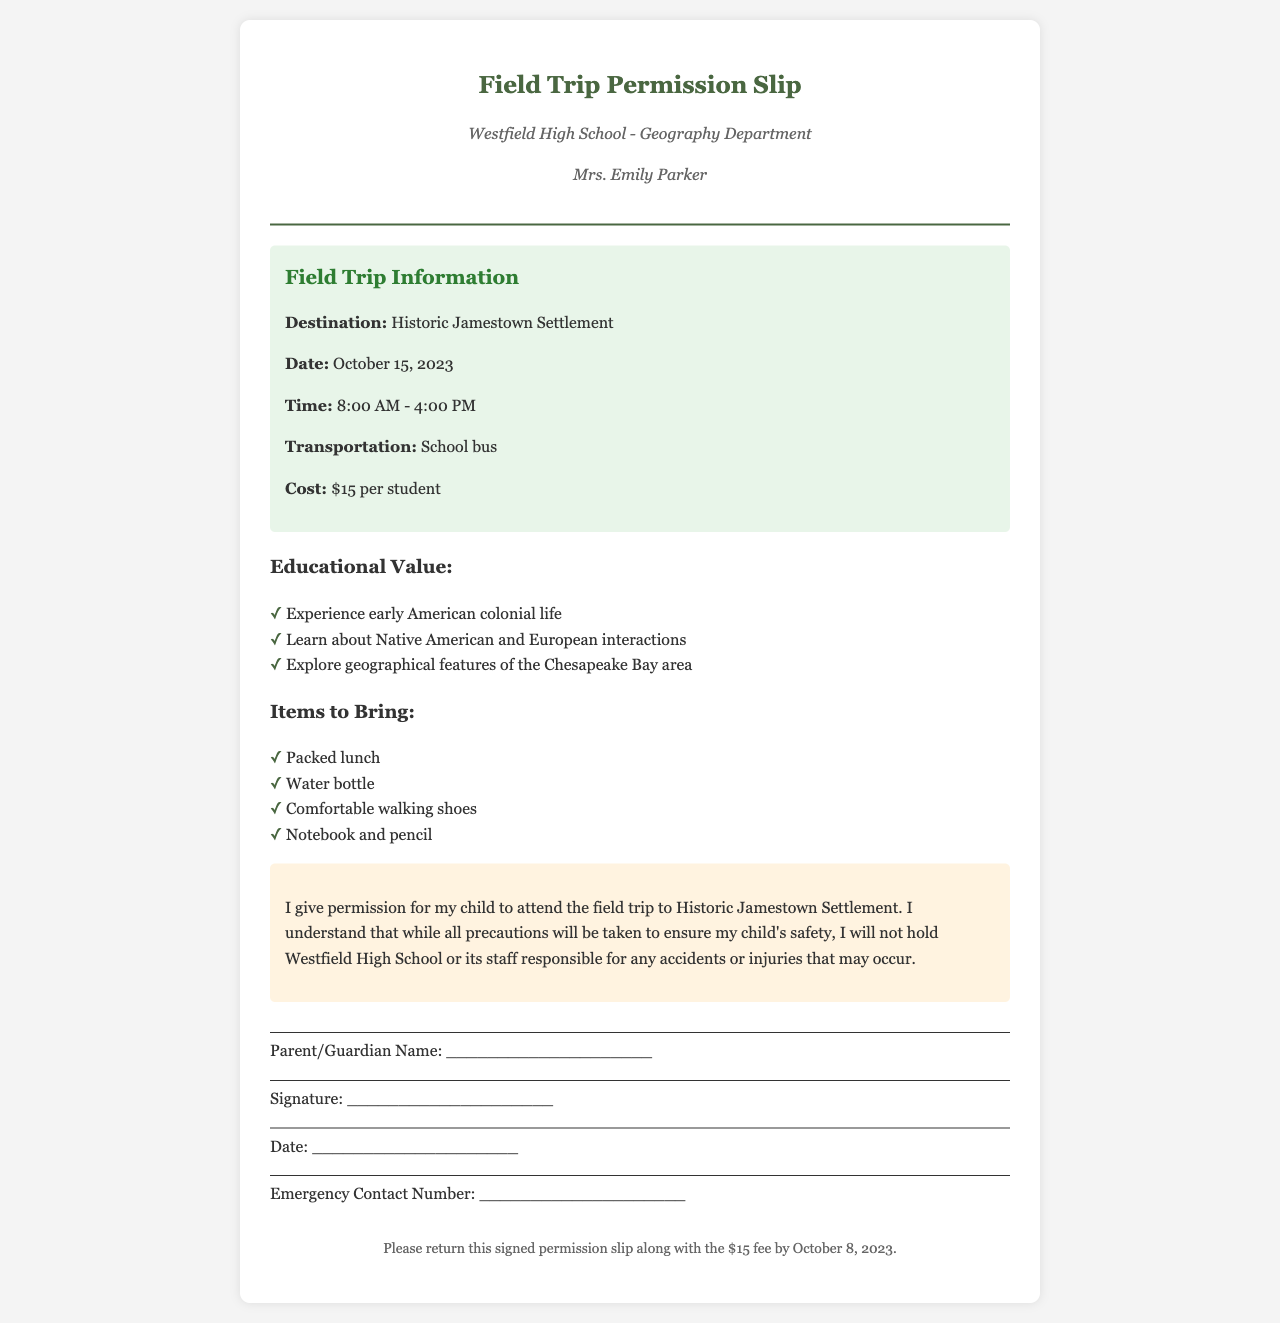What is the destination of the field trip? The destination is specified in the "Field Trip Information" section of the document as Historic Jamestown Settlement.
Answer: Historic Jamestown Settlement What is the cost for each student? The cost is stated directly in the "Field Trip Information" section as $15 per student.
Answer: $15 What is the date of the field trip? The date of the field trip is indicated in the "Field Trip Information" section, which mentions October 15, 2023.
Answer: October 15, 2023 What items should students bring? The items are listed under the "Items to Bring" section, which includes packed lunch, water bottle, comfortable walking shoes, and notebook and pencil.
Answer: Packed lunch, water bottle, comfortable walking shoes, notebook and pencil What is the deadline to return the permission slip? The deadline is provided in the footer of the document as October 8, 2023.
Answer: October 8, 2023 What transportation will be used for the trip? The transportation is noted in the "Field Trip Information" section as a school bus.
Answer: School bus Who is the teacher organizing the trip? The teacher's name is found in the header of the document, listed as Mrs. Emily Parker.
Answer: Mrs. Emily Parker What should parents understand regarding safety? The document states that parents understand they will not hold Westfield High School or its staff responsible for any accidents or injuries that may occur.
Answer: Not hold responsible for accidents or injuries 